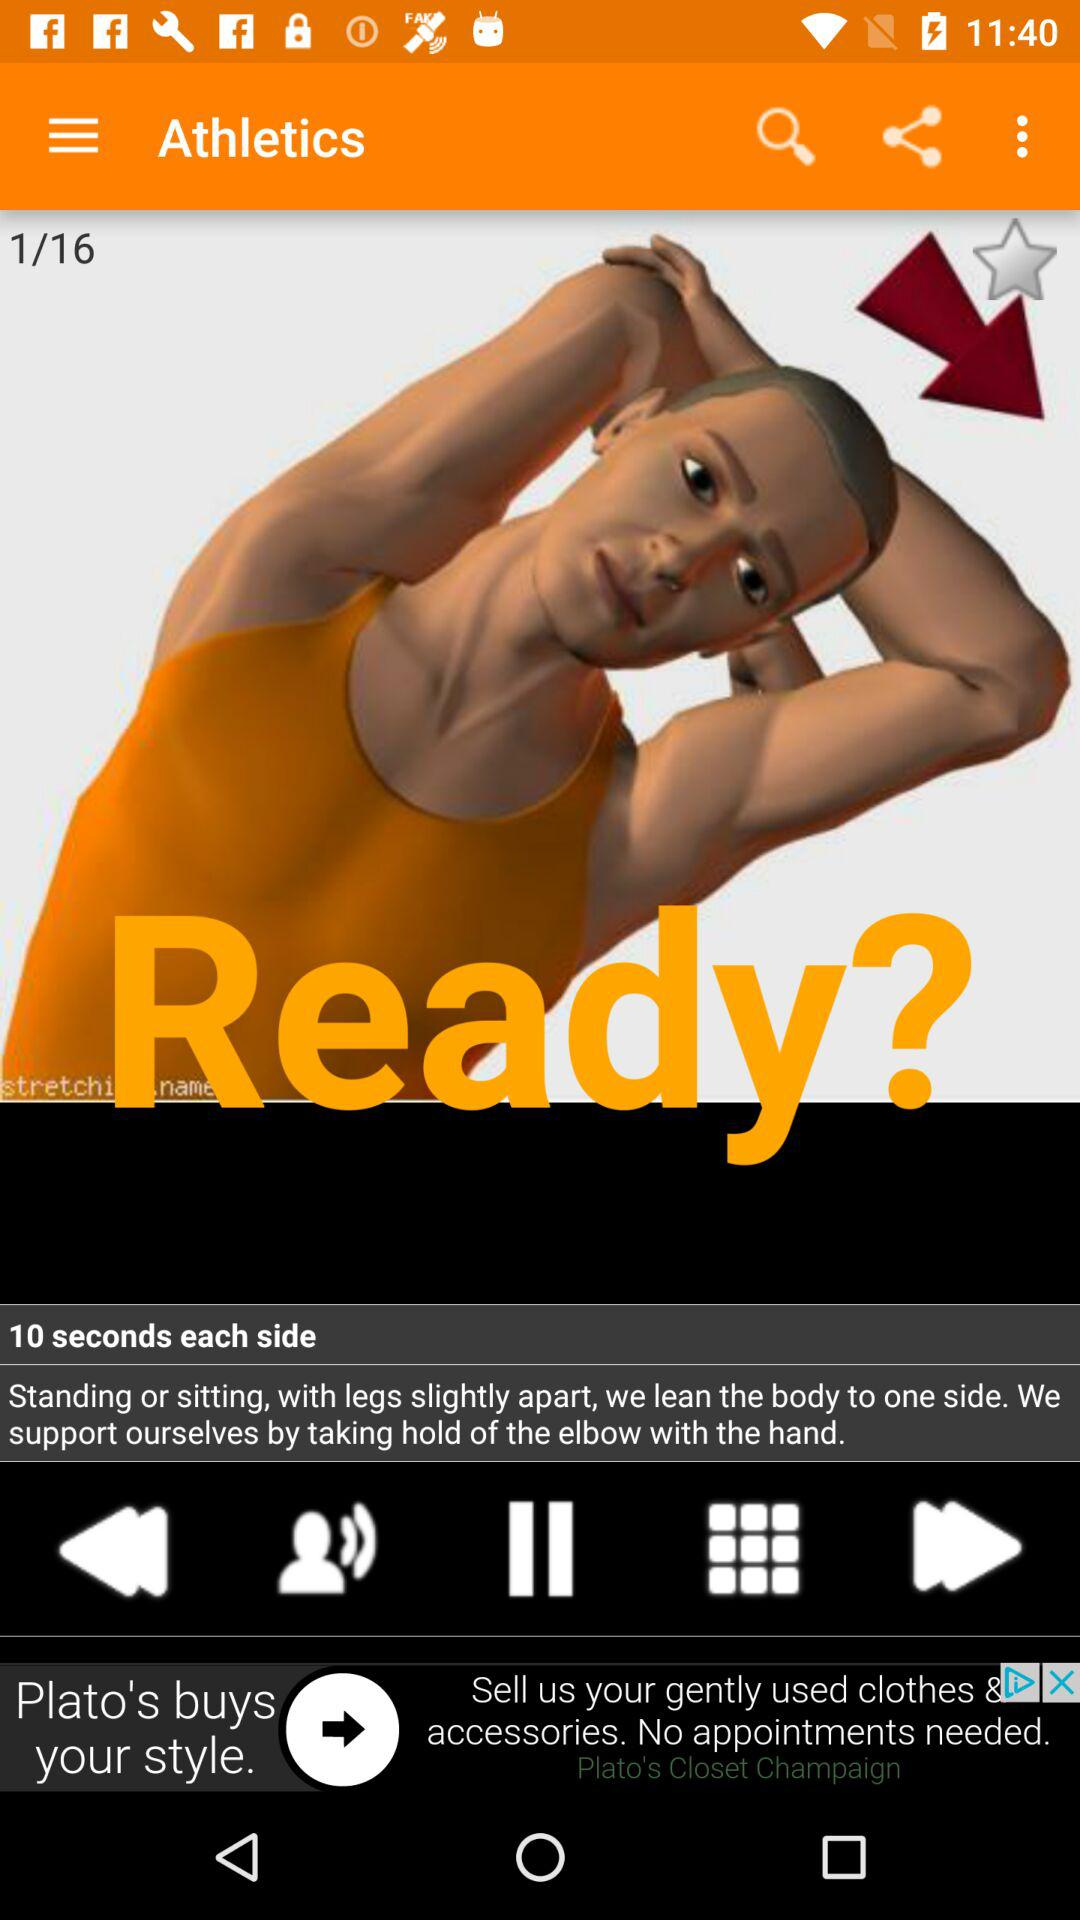Which slide am I on? You are on the first slide. 